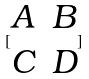Convert formula to latex. <formula><loc_0><loc_0><loc_500><loc_500>[ \begin{matrix} A & B \\ C & D \end{matrix} ]</formula> 